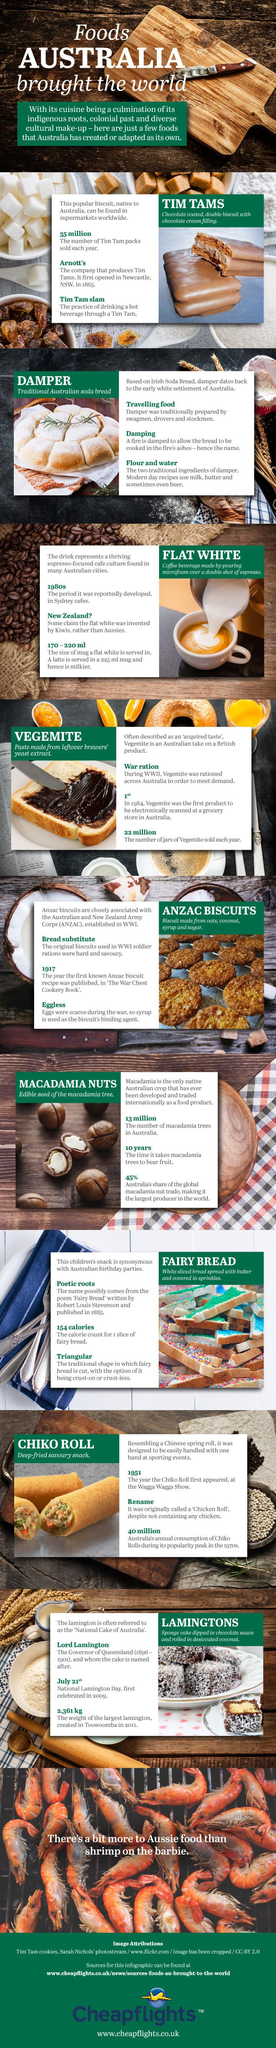Mention a couple of crucial points in this snapshot. It is the bread that is cooked over the ashes of a damp fire that is known as damper. The flat white is a coffee beverage that was reportedly developed in the 1980s in Sydney cafes. The latte is served in a bigger mug than the flat white. Tim Tam is the food item that is sold more each year than Vegemite. Anzac biscuits are made with syrup as the binding agent, as stated in the recipe. 